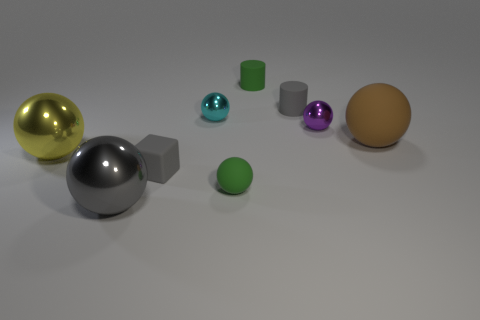Is the shape of the tiny metal thing on the left side of the gray matte cylinder the same as the small purple object that is right of the cyan metal thing?
Offer a very short reply. Yes. How many objects are matte objects or matte things that are in front of the rubber block?
Give a very brief answer. 5. There is a shiny thing that is the same color as the block; what shape is it?
Provide a succinct answer. Sphere. How many yellow spheres are the same size as the brown ball?
Your response must be concise. 1. What number of red things are either rubber objects or big objects?
Keep it short and to the point. 0. The small green object in front of the green object behind the small cyan ball is what shape?
Your answer should be very brief. Sphere. There is a metal thing that is the same size as the gray sphere; what shape is it?
Offer a terse response. Sphere. Is there a rubber sphere that has the same color as the rubber block?
Your answer should be very brief. No. Is the number of large yellow shiny objects behind the green cylinder the same as the number of tiny gray cylinders right of the tiny purple metallic ball?
Keep it short and to the point. Yes. There is a cyan thing; does it have the same shape as the big yellow object that is in front of the small purple thing?
Give a very brief answer. Yes. 